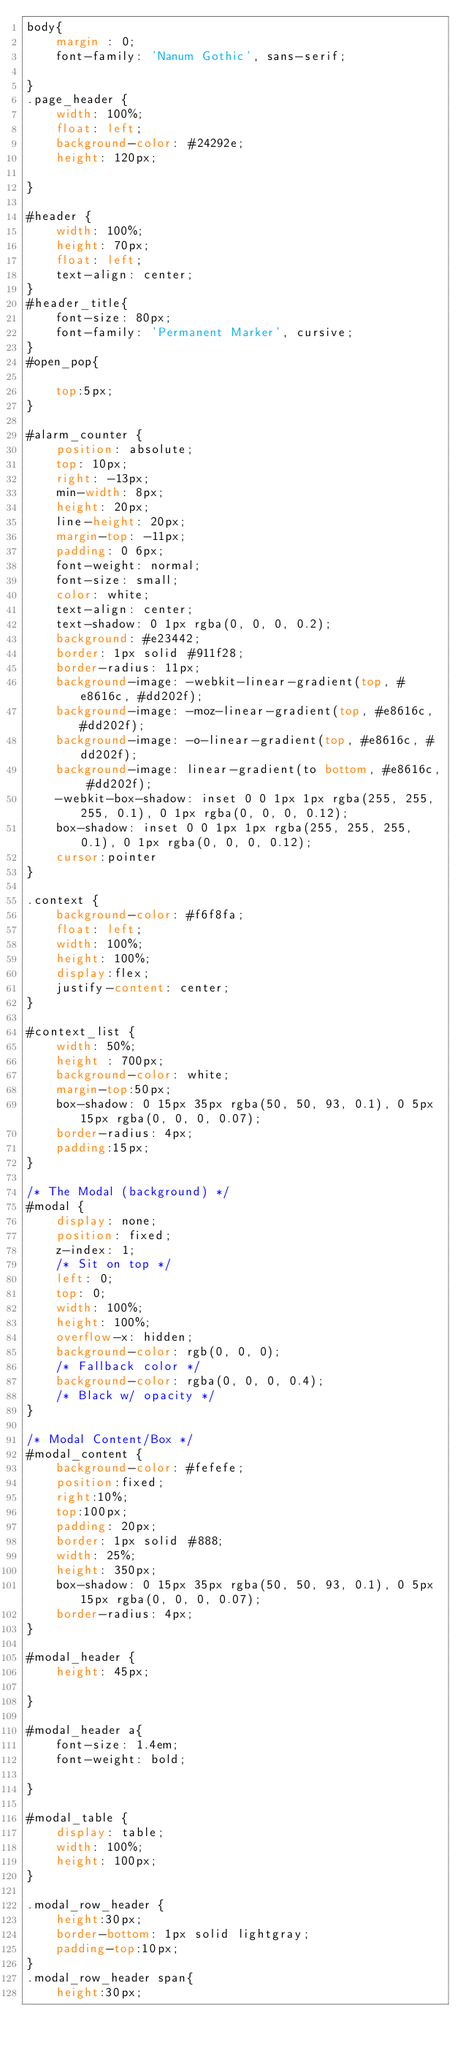<code> <loc_0><loc_0><loc_500><loc_500><_CSS_>body{
    margin : 0;
    font-family: 'Nanum Gothic', sans-serif;
    
}
.page_header {
    width: 100%;
    float: left;
    background-color: #24292e;
    height: 120px;

}

#header {
    width: 100%;
    height: 70px;
    float: left;
    text-align: center;
}
#header_title{
    font-size: 80px;
    font-family: 'Permanent Marker', cursive;
}
#open_pop{
    
    top:5px;
}

#alarm_counter {
    position: absolute;
    top: 10px;
    right: -13px;
    min-width: 8px;
    height: 20px;
    line-height: 20px;
    margin-top: -11px;
    padding: 0 6px;
    font-weight: normal;
    font-size: small;
    color: white;
    text-align: center;
    text-shadow: 0 1px rgba(0, 0, 0, 0.2);
    background: #e23442;
    border: 1px solid #911f28;
    border-radius: 11px;
    background-image: -webkit-linear-gradient(top, #e8616c, #dd202f);
    background-image: -moz-linear-gradient(top, #e8616c, #dd202f);
    background-image: -o-linear-gradient(top, #e8616c, #dd202f);
    background-image: linear-gradient(to bottom, #e8616c, #dd202f);
    -webkit-box-shadow: inset 0 0 1px 1px rgba(255, 255, 255, 0.1), 0 1px rgba(0, 0, 0, 0.12);
    box-shadow: inset 0 0 1px 1px rgba(255, 255, 255, 0.1), 0 1px rgba(0, 0, 0, 0.12);
    cursor:pointer
}

.context {
    background-color: #f6f8fa;
    float: left;
    width: 100%;
    height: 100%;
    display:flex;
    justify-content: center;
}

#context_list {
    width: 50%;
    height : 700px;    
    background-color: white;
    margin-top:50px;
    box-shadow: 0 15px 35px rgba(50, 50, 93, 0.1), 0 5px 15px rgba(0, 0, 0, 0.07);
    border-radius: 4px; 
    padding:15px;
}

/* The Modal (background) */
#modal {
    display: none;
    position: fixed;
    z-index: 1;
    /* Sit on top */
    left: 0;
    top: 0;
    width: 100%;
    height: 100%;
    overflow-x: hidden;
    background-color: rgb(0, 0, 0);
    /* Fallback color */
    background-color: rgba(0, 0, 0, 0.4);
    /* Black w/ opacity */
}

/* Modal Content/Box */
#modal_content {
    background-color: #fefefe;
    position:fixed;
    right:10%;
    top:100px;
    padding: 20px;
    border: 1px solid #888;
    width: 25%;
    height: 350px;
    box-shadow: 0 15px 35px rgba(50, 50, 93, 0.1), 0 5px 15px rgba(0, 0, 0, 0.07);
    border-radius: 4px; 
}

#modal_header {
    height: 45px;
    
}

#modal_header a{
    font-size: 1.4em;
    font-weight: bold;
    
}

#modal_table {
    display: table;
    width: 100%;
    height: 100px;
}

.modal_row_header {
    height:30px;
    border-bottom: 1px solid lightgray;
    padding-top:10px;
}
.modal_row_header span{
    height:30px;</code> 